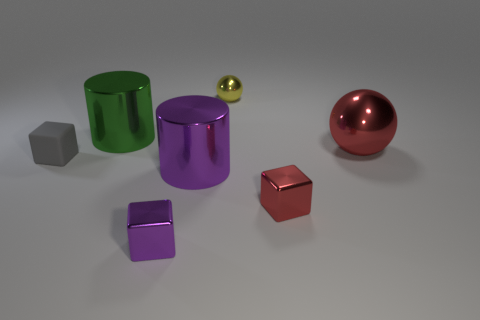Subtract all purple cubes. How many cubes are left? 2 Add 3 red metallic objects. How many objects exist? 10 Subtract all spheres. How many objects are left? 5 Subtract all red balls. How many balls are left? 1 Subtract 2 cylinders. How many cylinders are left? 0 Subtract all red spheres. Subtract all brown blocks. How many spheres are left? 1 Subtract all gray blocks. How many cyan cylinders are left? 0 Subtract all yellow shiny objects. Subtract all green objects. How many objects are left? 5 Add 5 tiny metallic balls. How many tiny metallic balls are left? 6 Add 5 purple objects. How many purple objects exist? 7 